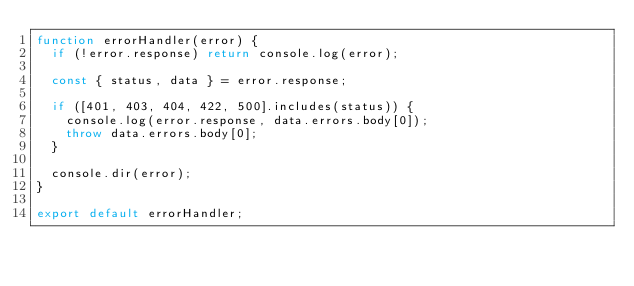<code> <loc_0><loc_0><loc_500><loc_500><_JavaScript_>function errorHandler(error) {
  if (!error.response) return console.log(error);

  const { status, data } = error.response;

  if ([401, 403, 404, 422, 500].includes(status)) {
    console.log(error.response, data.errors.body[0]);
    throw data.errors.body[0];
  }

  console.dir(error);
}

export default errorHandler;
</code> 